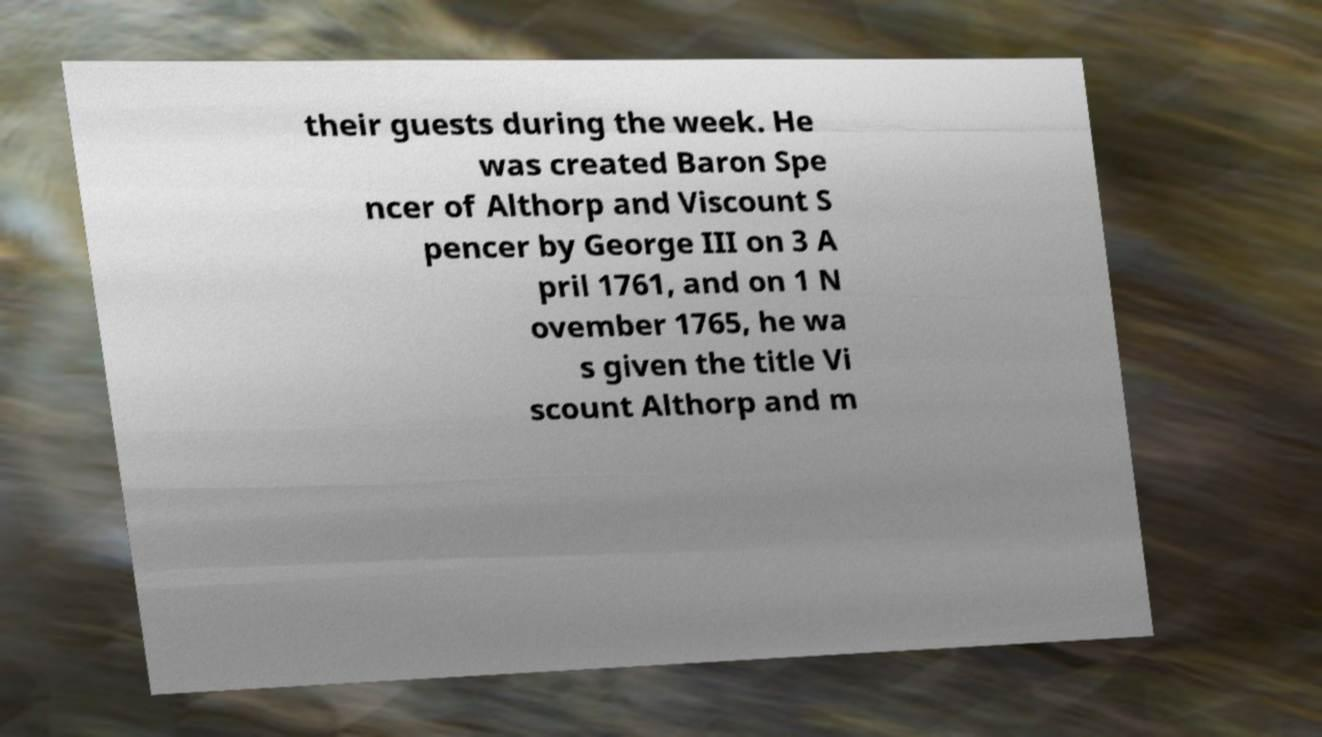For documentation purposes, I need the text within this image transcribed. Could you provide that? their guests during the week. He was created Baron Spe ncer of Althorp and Viscount S pencer by George III on 3 A pril 1761, and on 1 N ovember 1765, he wa s given the title Vi scount Althorp and m 